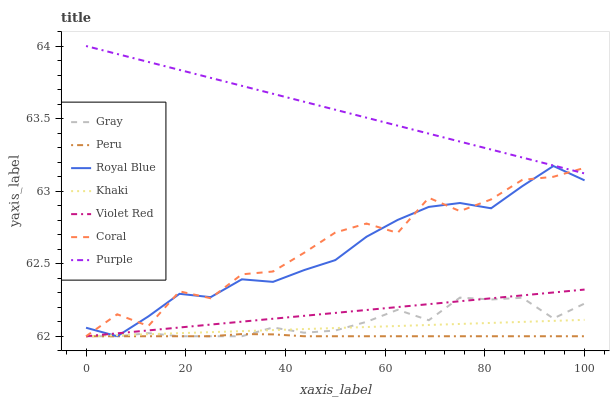Does Peru have the minimum area under the curve?
Answer yes or no. Yes. Does Purple have the maximum area under the curve?
Answer yes or no. Yes. Does Violet Red have the minimum area under the curve?
Answer yes or no. No. Does Violet Red have the maximum area under the curve?
Answer yes or no. No. Is Violet Red the smoothest?
Answer yes or no. Yes. Is Coral the roughest?
Answer yes or no. Yes. Is Khaki the smoothest?
Answer yes or no. No. Is Khaki the roughest?
Answer yes or no. No. Does Purple have the lowest value?
Answer yes or no. No. Does Purple have the highest value?
Answer yes or no. Yes. Does Violet Red have the highest value?
Answer yes or no. No. Is Peru less than Purple?
Answer yes or no. Yes. Is Purple greater than Gray?
Answer yes or no. Yes. Does Gray intersect Violet Red?
Answer yes or no. Yes. Is Gray less than Violet Red?
Answer yes or no. No. Is Gray greater than Violet Red?
Answer yes or no. No. Does Peru intersect Purple?
Answer yes or no. No. 